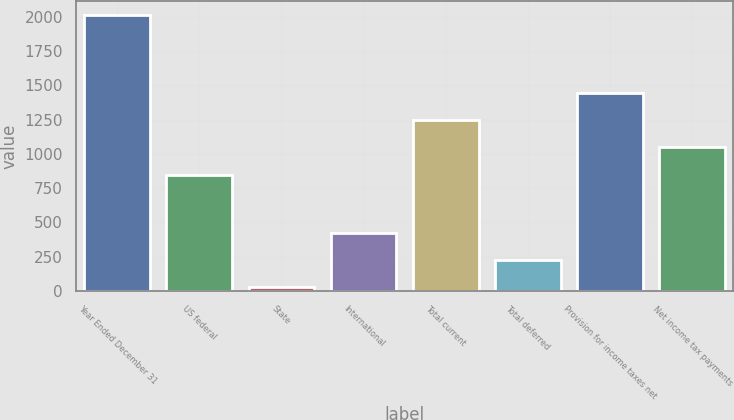Convert chart to OTSL. <chart><loc_0><loc_0><loc_500><loc_500><bar_chart><fcel>Year Ended December 31<fcel>US federal<fcel>State<fcel>International<fcel>Total current<fcel>Total deferred<fcel>Provision for income taxes net<fcel>Net income tax payments<nl><fcel>2013<fcel>850<fcel>28<fcel>425<fcel>1247<fcel>226.5<fcel>1445.5<fcel>1048.5<nl></chart> 